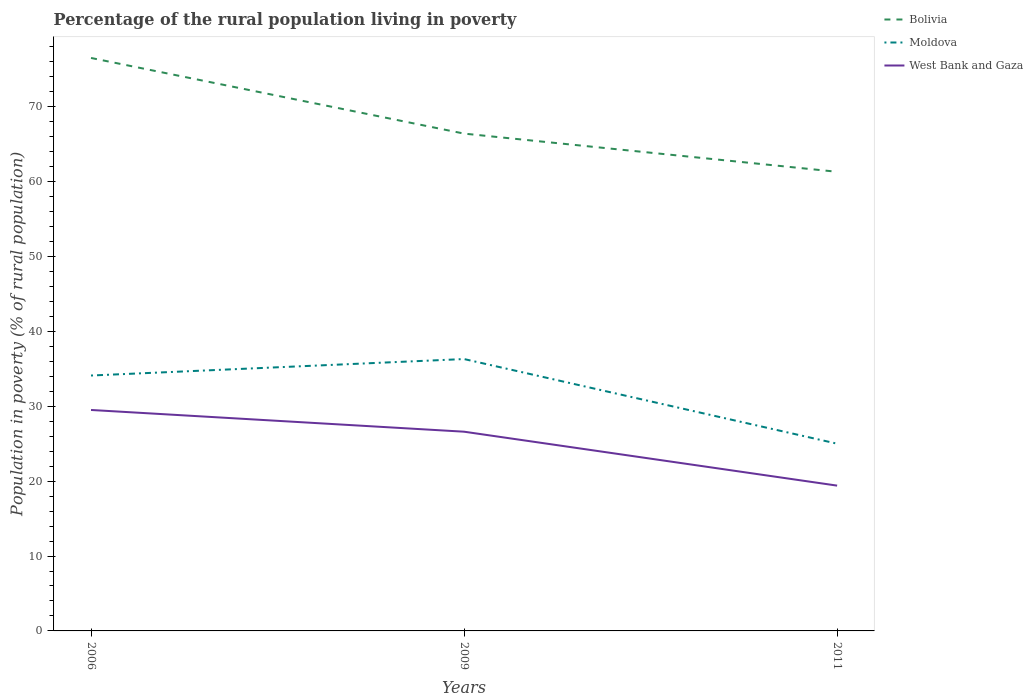Across all years, what is the maximum percentage of the rural population living in poverty in Moldova?
Keep it short and to the point. 25. What is the total percentage of the rural population living in poverty in West Bank and Gaza in the graph?
Your answer should be compact. 10.1. What is the difference between the highest and the second highest percentage of the rural population living in poverty in West Bank and Gaza?
Ensure brevity in your answer.  10.1. What is the difference between the highest and the lowest percentage of the rural population living in poverty in Moldova?
Give a very brief answer. 2. How many lines are there?
Give a very brief answer. 3. What is the difference between two consecutive major ticks on the Y-axis?
Ensure brevity in your answer.  10. Are the values on the major ticks of Y-axis written in scientific E-notation?
Your answer should be very brief. No. Does the graph contain any zero values?
Provide a short and direct response. No. Does the graph contain grids?
Keep it short and to the point. No. What is the title of the graph?
Offer a very short reply. Percentage of the rural population living in poverty. Does "Mexico" appear as one of the legend labels in the graph?
Provide a succinct answer. No. What is the label or title of the Y-axis?
Your response must be concise. Population in poverty (% of rural population). What is the Population in poverty (% of rural population) of Bolivia in 2006?
Offer a terse response. 76.5. What is the Population in poverty (% of rural population) of Moldova in 2006?
Keep it short and to the point. 34.1. What is the Population in poverty (% of rural population) in West Bank and Gaza in 2006?
Provide a short and direct response. 29.5. What is the Population in poverty (% of rural population) in Bolivia in 2009?
Ensure brevity in your answer.  66.4. What is the Population in poverty (% of rural population) in Moldova in 2009?
Your response must be concise. 36.3. What is the Population in poverty (% of rural population) of West Bank and Gaza in 2009?
Provide a succinct answer. 26.6. What is the Population in poverty (% of rural population) in Bolivia in 2011?
Offer a very short reply. 61.3. Across all years, what is the maximum Population in poverty (% of rural population) in Bolivia?
Offer a terse response. 76.5. Across all years, what is the maximum Population in poverty (% of rural population) in Moldova?
Make the answer very short. 36.3. Across all years, what is the maximum Population in poverty (% of rural population) in West Bank and Gaza?
Ensure brevity in your answer.  29.5. Across all years, what is the minimum Population in poverty (% of rural population) in Bolivia?
Your answer should be compact. 61.3. Across all years, what is the minimum Population in poverty (% of rural population) in Moldova?
Give a very brief answer. 25. What is the total Population in poverty (% of rural population) in Bolivia in the graph?
Ensure brevity in your answer.  204.2. What is the total Population in poverty (% of rural population) in Moldova in the graph?
Give a very brief answer. 95.4. What is the total Population in poverty (% of rural population) in West Bank and Gaza in the graph?
Offer a very short reply. 75.5. What is the difference between the Population in poverty (% of rural population) of Bolivia in 2006 and that in 2009?
Keep it short and to the point. 10.1. What is the difference between the Population in poverty (% of rural population) in West Bank and Gaza in 2006 and that in 2009?
Provide a succinct answer. 2.9. What is the difference between the Population in poverty (% of rural population) of Bolivia in 2006 and that in 2011?
Offer a terse response. 15.2. What is the difference between the Population in poverty (% of rural population) in Moldova in 2006 and that in 2011?
Ensure brevity in your answer.  9.1. What is the difference between the Population in poverty (% of rural population) of Bolivia in 2009 and that in 2011?
Make the answer very short. 5.1. What is the difference between the Population in poverty (% of rural population) of Moldova in 2009 and that in 2011?
Give a very brief answer. 11.3. What is the difference between the Population in poverty (% of rural population) in West Bank and Gaza in 2009 and that in 2011?
Keep it short and to the point. 7.2. What is the difference between the Population in poverty (% of rural population) in Bolivia in 2006 and the Population in poverty (% of rural population) in Moldova in 2009?
Your answer should be very brief. 40.2. What is the difference between the Population in poverty (% of rural population) in Bolivia in 2006 and the Population in poverty (% of rural population) in West Bank and Gaza in 2009?
Your response must be concise. 49.9. What is the difference between the Population in poverty (% of rural population) in Bolivia in 2006 and the Population in poverty (% of rural population) in Moldova in 2011?
Keep it short and to the point. 51.5. What is the difference between the Population in poverty (% of rural population) of Bolivia in 2006 and the Population in poverty (% of rural population) of West Bank and Gaza in 2011?
Keep it short and to the point. 57.1. What is the difference between the Population in poverty (% of rural population) in Bolivia in 2009 and the Population in poverty (% of rural population) in Moldova in 2011?
Your answer should be very brief. 41.4. What is the average Population in poverty (% of rural population) in Bolivia per year?
Offer a terse response. 68.07. What is the average Population in poverty (% of rural population) of Moldova per year?
Your response must be concise. 31.8. What is the average Population in poverty (% of rural population) of West Bank and Gaza per year?
Your answer should be compact. 25.17. In the year 2006, what is the difference between the Population in poverty (% of rural population) in Bolivia and Population in poverty (% of rural population) in Moldova?
Provide a short and direct response. 42.4. In the year 2006, what is the difference between the Population in poverty (% of rural population) in Moldova and Population in poverty (% of rural population) in West Bank and Gaza?
Provide a short and direct response. 4.6. In the year 2009, what is the difference between the Population in poverty (% of rural population) in Bolivia and Population in poverty (% of rural population) in Moldova?
Your answer should be compact. 30.1. In the year 2009, what is the difference between the Population in poverty (% of rural population) of Bolivia and Population in poverty (% of rural population) of West Bank and Gaza?
Provide a succinct answer. 39.8. In the year 2011, what is the difference between the Population in poverty (% of rural population) of Bolivia and Population in poverty (% of rural population) of Moldova?
Offer a terse response. 36.3. In the year 2011, what is the difference between the Population in poverty (% of rural population) in Bolivia and Population in poverty (% of rural population) in West Bank and Gaza?
Provide a succinct answer. 41.9. What is the ratio of the Population in poverty (% of rural population) of Bolivia in 2006 to that in 2009?
Provide a succinct answer. 1.15. What is the ratio of the Population in poverty (% of rural population) of Moldova in 2006 to that in 2009?
Ensure brevity in your answer.  0.94. What is the ratio of the Population in poverty (% of rural population) in West Bank and Gaza in 2006 to that in 2009?
Ensure brevity in your answer.  1.11. What is the ratio of the Population in poverty (% of rural population) in Bolivia in 2006 to that in 2011?
Ensure brevity in your answer.  1.25. What is the ratio of the Population in poverty (% of rural population) of Moldova in 2006 to that in 2011?
Offer a terse response. 1.36. What is the ratio of the Population in poverty (% of rural population) in West Bank and Gaza in 2006 to that in 2011?
Provide a succinct answer. 1.52. What is the ratio of the Population in poverty (% of rural population) in Bolivia in 2009 to that in 2011?
Your answer should be compact. 1.08. What is the ratio of the Population in poverty (% of rural population) of Moldova in 2009 to that in 2011?
Ensure brevity in your answer.  1.45. What is the ratio of the Population in poverty (% of rural population) in West Bank and Gaza in 2009 to that in 2011?
Keep it short and to the point. 1.37. What is the difference between the highest and the second highest Population in poverty (% of rural population) in West Bank and Gaza?
Your answer should be very brief. 2.9. What is the difference between the highest and the lowest Population in poverty (% of rural population) in Bolivia?
Ensure brevity in your answer.  15.2. What is the difference between the highest and the lowest Population in poverty (% of rural population) of Moldova?
Offer a very short reply. 11.3. What is the difference between the highest and the lowest Population in poverty (% of rural population) in West Bank and Gaza?
Provide a short and direct response. 10.1. 